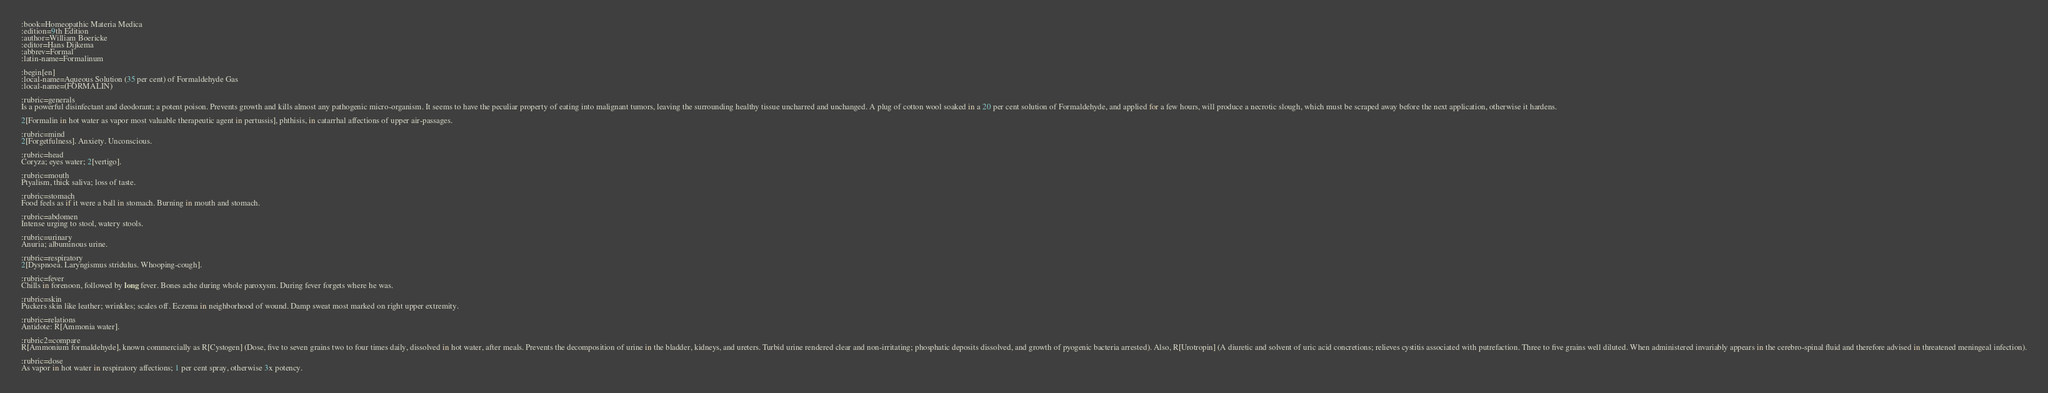Convert code to text. <code><loc_0><loc_0><loc_500><loc_500><_ObjectiveC_>:book=Homeopathic Materia Medica
:edition=9th Edition
:author=William Boericke
:editor=Hans Dijkema
:abbrev=Formal
:latin-name=Formalinum

:begin[en]
:local-name=Aqueous Solution (35 per cent) of Formaldehyde Gas
:local-name=(FORMALIN)

:rubric=generals
Is a powerful disinfectant and deodorant; a potent poison. Prevents growth and kills almost any pathogenic micro-organism. It seems to have the peculiar property of eating into malignant tumors, leaving the surrounding healthy tissue uncharred and unchanged. A plug of cotton wool soaked in a 20 per cent solution of Formaldehyde, and applied for a few hours, will produce a necrotic slough, which must be scraped away before the next application, otherwise it hardens.

2[Formalin in hot water as vapor most valuable therapeutic agent in pertussis], phthisis, in catarrhal affections of upper air-passages.

:rubric=mind
2[Forgetfulness]. Anxiety. Unconscious.

:rubric=head
Coryza; eyes water; 2[vertigo].

:rubric=mouth
Ptyalism, thick saliva; loss of taste.

:rubric=stomach
Food feels as if it were a ball in stomach. Burning in mouth and stomach.

:rubric=abdomen
Intense urging to stool, watery stools.

:rubric=urinary
Anuria; albuminous urine.

:rubric=respiratory
2[Dyspnoea. Laryngismus stridulus. Whooping-cough].

:rubric=fever
Chills in forenoon, followed by long fever. Bones ache during whole paroxysm. During fever forgets where he was.

:rubric=skin
Puckers skin like leather; wrinkles; scales off. Eczema in neighborhood of wound. Damp sweat most marked on right upper extremity.

:rubric=relations
Antidote: R[Ammonia water].

:rubric2=compare
R[Ammonium formaldehyde], known commercially as R[Cystogen] (Dose, five to seven grains two to four times daily, dissolved in hot water, after meals. Prevents the decomposition of urine in the bladder, kidneys, and ureters. Turbid urine rendered clear and non-irritating; phosphatic deposits dissolved, and growth of pyogenic bacteria arrested). Also, R[Urotropin] (A diuretic and solvent of uric acid concretions; relieves cystitis associated with putrefaction. Three to five grains well diluted. When administered invariably appears in the cerebro-spinal fluid and therefore advised in threatened meningeal infection).

:rubric=dose
As vapor in hot water in respiratory affections; 1 per cent spray, otherwise 3x potency.

</code> 